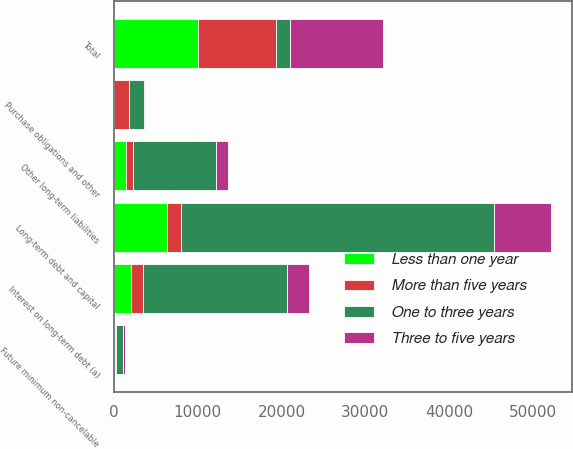<chart> <loc_0><loc_0><loc_500><loc_500><stacked_bar_chart><ecel><fcel>Long-term debt and capital<fcel>Interest on long-term debt (a)<fcel>Future minimum non-cancelable<fcel>Purchase obligations and other<fcel>Other long-term liabilities<fcel>Total<nl><fcel>One to three years<fcel>37360<fcel>17204<fcel>809<fcel>1843<fcel>9994<fcel>1710<nl><fcel>More than five years<fcel>1612<fcel>1433<fcel>116<fcel>1710<fcel>736<fcel>9306<nl><fcel>Three to five years<fcel>6808<fcel>2613<fcel>205<fcel>110<fcel>1392<fcel>11128<nl><fcel>Less than one year<fcel>6370<fcel>2024<fcel>145<fcel>21<fcel>1478<fcel>10038<nl></chart> 